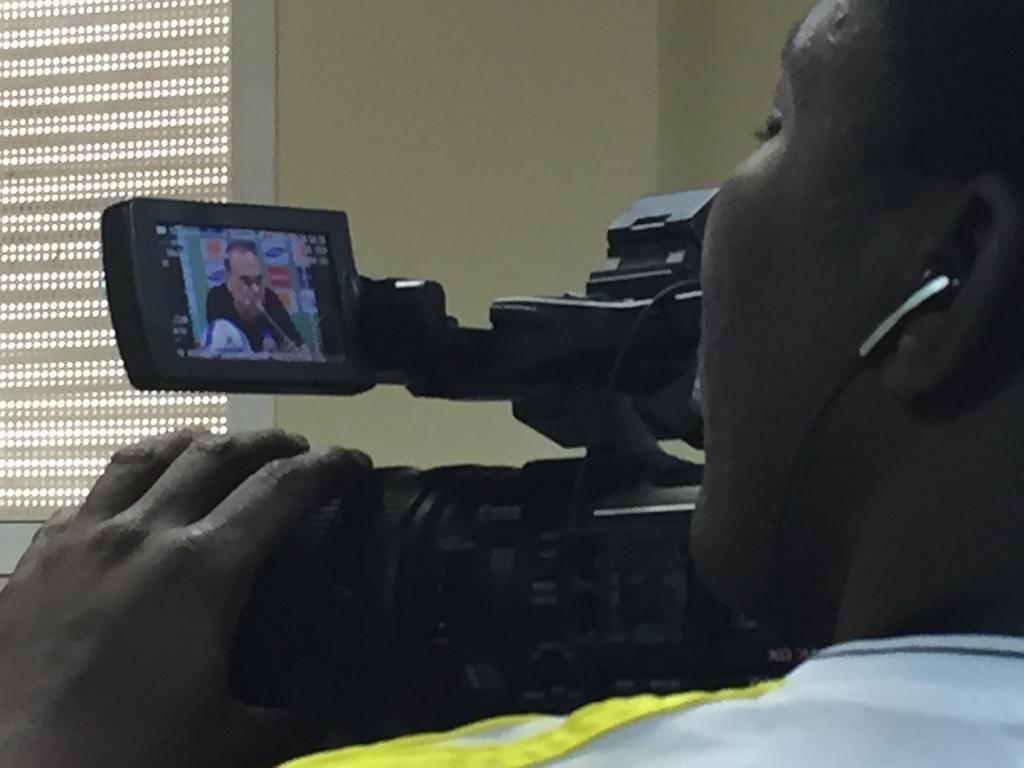Could you give a brief overview of what you see in this image? In this image a person is holding a camera and watching the video screen, listening the audio. 